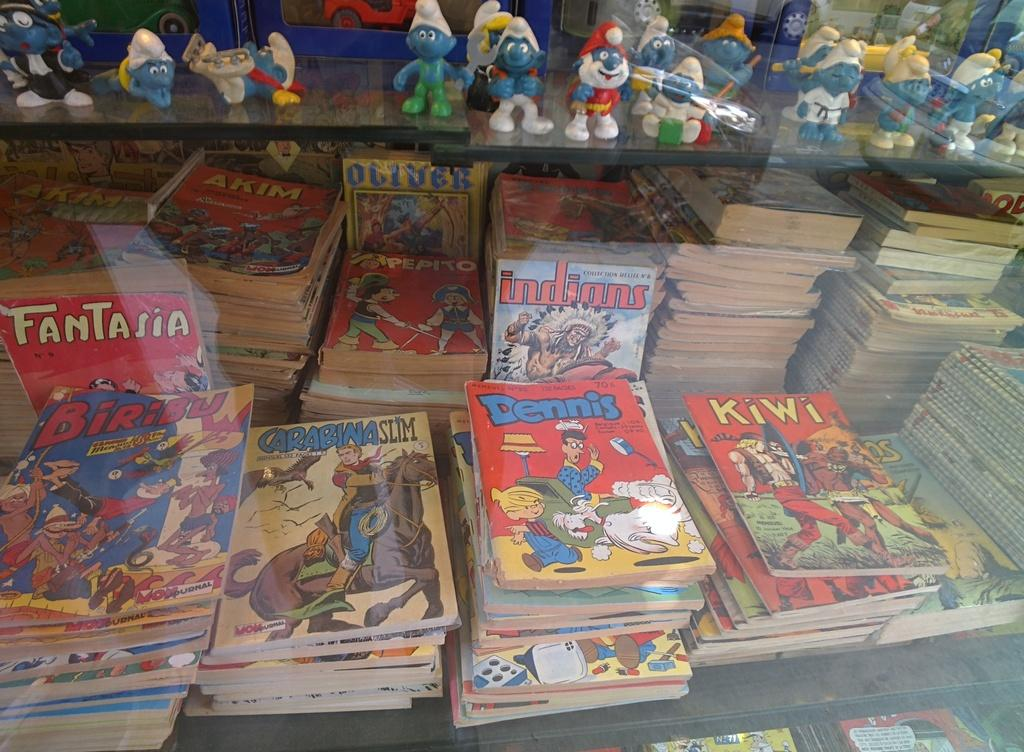<image>
Write a terse but informative summary of the picture. A collection of comics includes the titles Dennis, Biribu, and Kiwi. 